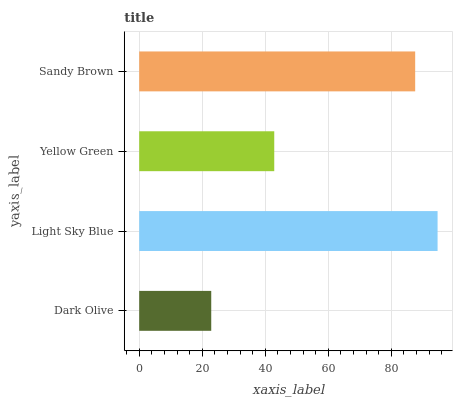Is Dark Olive the minimum?
Answer yes or no. Yes. Is Light Sky Blue the maximum?
Answer yes or no. Yes. Is Yellow Green the minimum?
Answer yes or no. No. Is Yellow Green the maximum?
Answer yes or no. No. Is Light Sky Blue greater than Yellow Green?
Answer yes or no. Yes. Is Yellow Green less than Light Sky Blue?
Answer yes or no. Yes. Is Yellow Green greater than Light Sky Blue?
Answer yes or no. No. Is Light Sky Blue less than Yellow Green?
Answer yes or no. No. Is Sandy Brown the high median?
Answer yes or no. Yes. Is Yellow Green the low median?
Answer yes or no. Yes. Is Dark Olive the high median?
Answer yes or no. No. Is Light Sky Blue the low median?
Answer yes or no. No. 